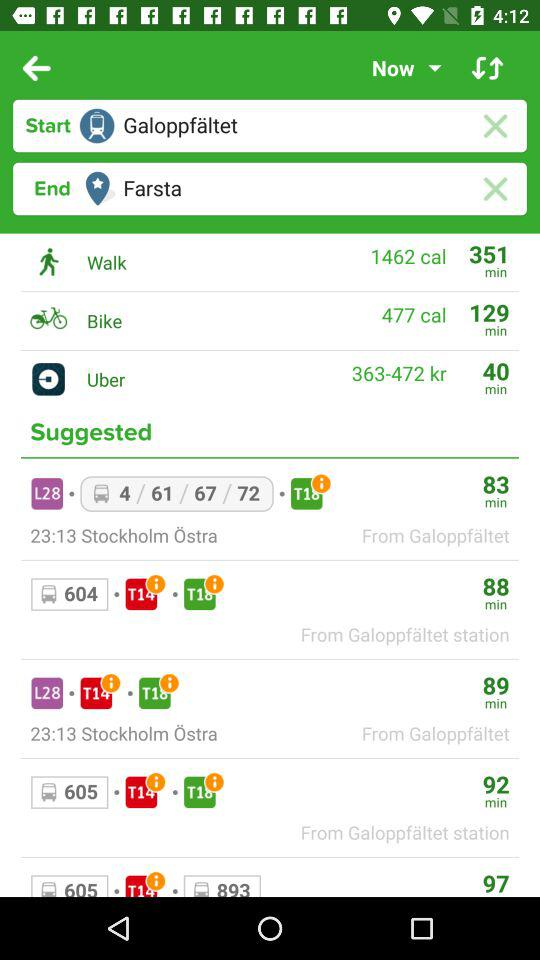What is the start location? The start location is "Galoppfaltet". 